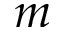Convert formula to latex. <formula><loc_0><loc_0><loc_500><loc_500>m</formula> 